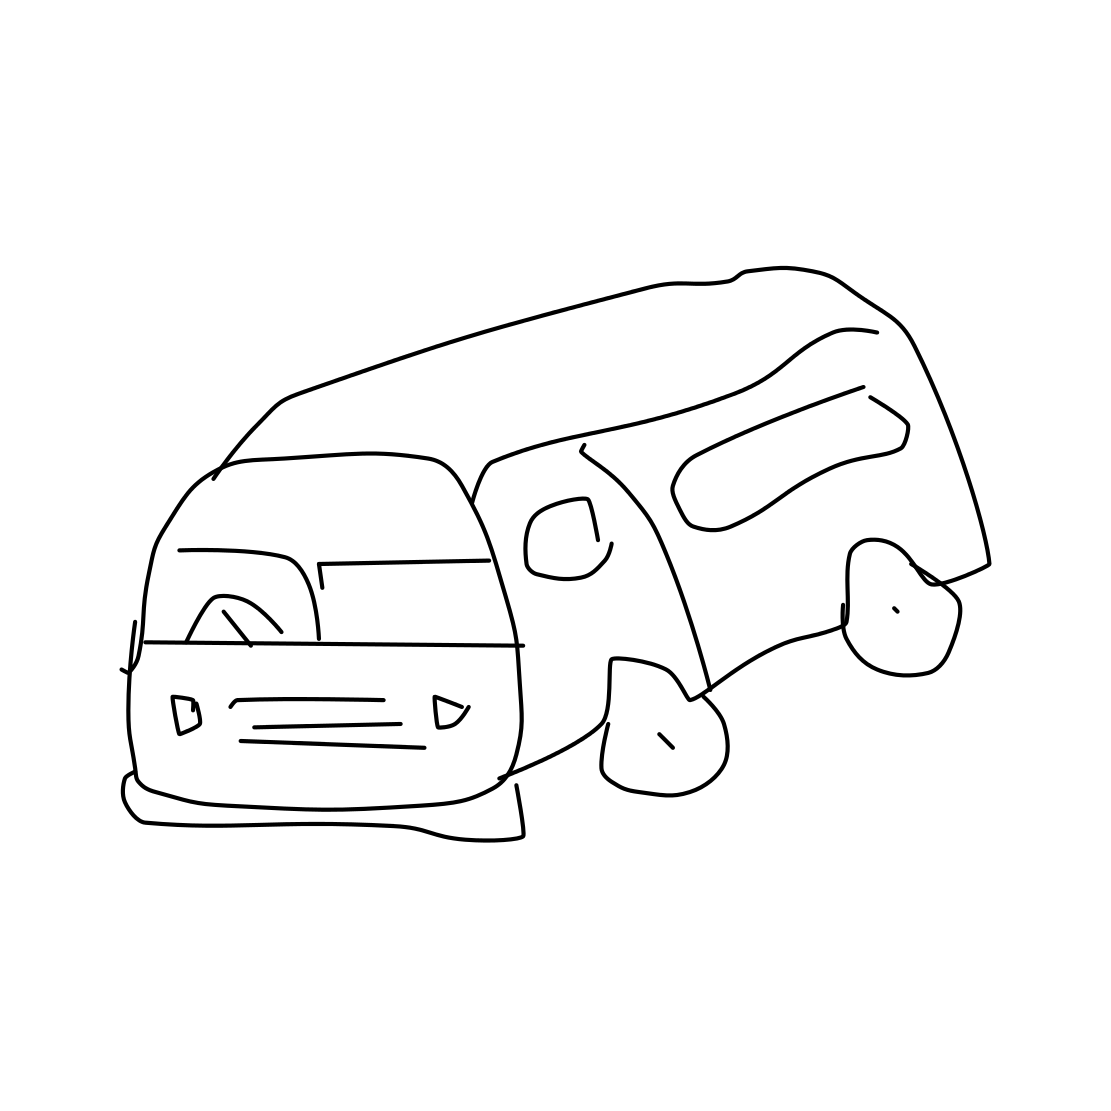Could this sketch be part of a larger story or concept? Certainly, the sketch could be a conceptual design for a character's vehicle in a story or part of a storyboard for an animation. Its simplicity leaves plenty of room for imagination, allowing it to fit into a narrative about travel, adventure, or a character with a nomadic lifestyle. 